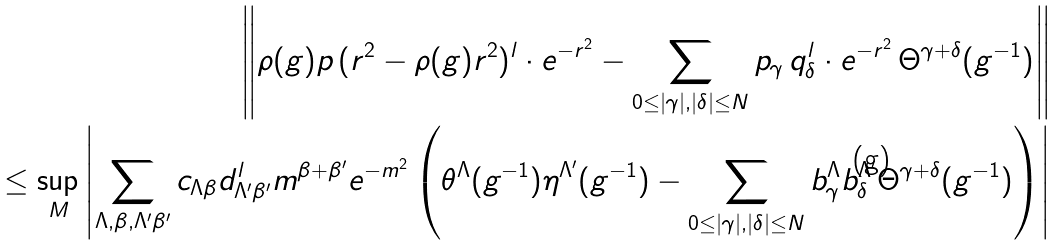Convert formula to latex. <formula><loc_0><loc_0><loc_500><loc_500>\left \| \rho ( g ) p \, ( r ^ { 2 } - \rho ( g ) r ^ { 2 } ) ^ { l } \cdot e ^ { - r ^ { 2 } } - \sum _ { 0 \leq | \gamma | , | \delta | \leq N } p _ { \gamma } \, q _ { \delta } ^ { l } \cdot e ^ { - r ^ { 2 } } \, \Theta ^ { \gamma + \delta } ( g ^ { - 1 } ) \right \| \\ \leq \sup _ { M } \left | \sum _ { \Lambda , \beta , \Lambda ^ { \prime } \beta ^ { \prime } } c _ { \Lambda \beta } d _ { \Lambda ^ { \prime } \beta ^ { \prime } } ^ { l } m ^ { \beta + \beta ^ { \prime } } e ^ { - m ^ { 2 } } \left ( \theta ^ { \Lambda } ( g ^ { - 1 } ) \eta ^ { \Lambda ^ { \prime } } ( g ^ { - 1 } ) - \sum _ { 0 \leq | \gamma | , | \delta | \leq N } b ^ { \Lambda } _ { \gamma } b ^ { \Lambda ^ { \prime } } _ { \delta } \Theta ^ { \gamma + \delta } ( g ^ { - 1 } ) \right ) \right | \\</formula> 